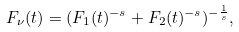<formula> <loc_0><loc_0><loc_500><loc_500>F _ { \nu } ( t ) = ( F _ { 1 } ( t ) ^ { - s } + F _ { 2 } ( t ) ^ { - s } ) ^ { - \frac { 1 } { s } } ,</formula> 